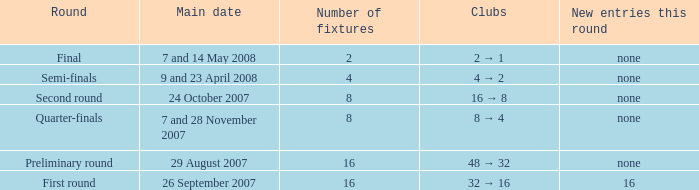What is the Round when the number of fixtures is more than 2, and the Main date of 7 and 28 november 2007? Quarter-finals. 